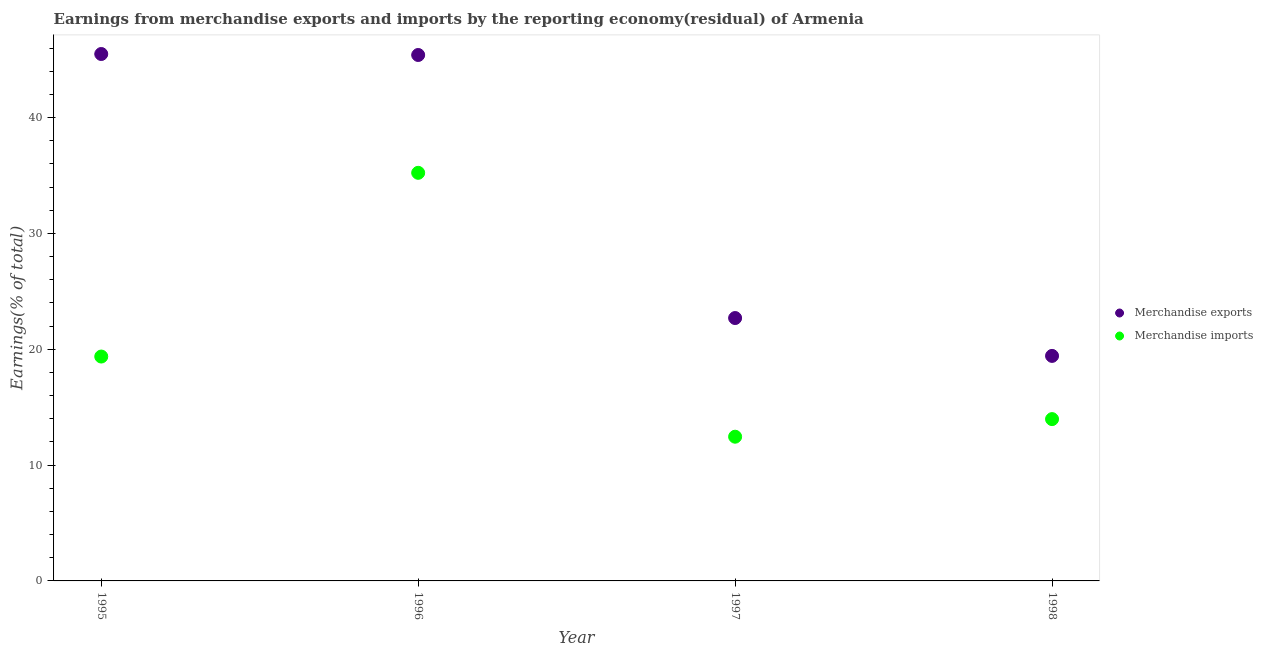Is the number of dotlines equal to the number of legend labels?
Ensure brevity in your answer.  Yes. What is the earnings from merchandise exports in 1996?
Give a very brief answer. 45.4. Across all years, what is the maximum earnings from merchandise imports?
Keep it short and to the point. 35.23. Across all years, what is the minimum earnings from merchandise imports?
Your response must be concise. 12.45. In which year was the earnings from merchandise imports maximum?
Provide a short and direct response. 1996. What is the total earnings from merchandise imports in the graph?
Provide a short and direct response. 81.01. What is the difference between the earnings from merchandise imports in 1995 and that in 1997?
Ensure brevity in your answer.  6.92. What is the difference between the earnings from merchandise exports in 1996 and the earnings from merchandise imports in 1998?
Your response must be concise. 31.43. What is the average earnings from merchandise imports per year?
Provide a short and direct response. 20.25. In the year 1995, what is the difference between the earnings from merchandise imports and earnings from merchandise exports?
Ensure brevity in your answer.  -26.12. What is the ratio of the earnings from merchandise exports in 1995 to that in 1997?
Your answer should be very brief. 2. What is the difference between the highest and the second highest earnings from merchandise exports?
Offer a very short reply. 0.08. What is the difference between the highest and the lowest earnings from merchandise exports?
Provide a succinct answer. 26.06. Is the sum of the earnings from merchandise imports in 1995 and 1996 greater than the maximum earnings from merchandise exports across all years?
Give a very brief answer. Yes. Is the earnings from merchandise exports strictly greater than the earnings from merchandise imports over the years?
Provide a succinct answer. Yes. Is the earnings from merchandise imports strictly less than the earnings from merchandise exports over the years?
Make the answer very short. Yes. How many dotlines are there?
Give a very brief answer. 2. How many years are there in the graph?
Offer a terse response. 4. Are the values on the major ticks of Y-axis written in scientific E-notation?
Your answer should be compact. No. Does the graph contain any zero values?
Provide a succinct answer. No. Does the graph contain grids?
Give a very brief answer. No. Where does the legend appear in the graph?
Offer a very short reply. Center right. How many legend labels are there?
Give a very brief answer. 2. What is the title of the graph?
Your answer should be very brief. Earnings from merchandise exports and imports by the reporting economy(residual) of Armenia. Does "Male labourers" appear as one of the legend labels in the graph?
Give a very brief answer. No. What is the label or title of the Y-axis?
Offer a terse response. Earnings(% of total). What is the Earnings(% of total) of Merchandise exports in 1995?
Ensure brevity in your answer.  45.48. What is the Earnings(% of total) in Merchandise imports in 1995?
Make the answer very short. 19.37. What is the Earnings(% of total) of Merchandise exports in 1996?
Ensure brevity in your answer.  45.4. What is the Earnings(% of total) of Merchandise imports in 1996?
Give a very brief answer. 35.23. What is the Earnings(% of total) of Merchandise exports in 1997?
Your answer should be compact. 22.69. What is the Earnings(% of total) of Merchandise imports in 1997?
Provide a succinct answer. 12.45. What is the Earnings(% of total) of Merchandise exports in 1998?
Provide a succinct answer. 19.42. What is the Earnings(% of total) of Merchandise imports in 1998?
Your answer should be very brief. 13.97. Across all years, what is the maximum Earnings(% of total) in Merchandise exports?
Offer a very short reply. 45.48. Across all years, what is the maximum Earnings(% of total) in Merchandise imports?
Provide a short and direct response. 35.23. Across all years, what is the minimum Earnings(% of total) of Merchandise exports?
Offer a terse response. 19.42. Across all years, what is the minimum Earnings(% of total) in Merchandise imports?
Keep it short and to the point. 12.45. What is the total Earnings(% of total) in Merchandise exports in the graph?
Your answer should be very brief. 133. What is the total Earnings(% of total) of Merchandise imports in the graph?
Your response must be concise. 81.01. What is the difference between the Earnings(% of total) of Merchandise exports in 1995 and that in 1996?
Your answer should be compact. 0.08. What is the difference between the Earnings(% of total) of Merchandise imports in 1995 and that in 1996?
Your answer should be very brief. -15.86. What is the difference between the Earnings(% of total) of Merchandise exports in 1995 and that in 1997?
Provide a succinct answer. 22.79. What is the difference between the Earnings(% of total) in Merchandise imports in 1995 and that in 1997?
Offer a terse response. 6.92. What is the difference between the Earnings(% of total) in Merchandise exports in 1995 and that in 1998?
Make the answer very short. 26.06. What is the difference between the Earnings(% of total) of Merchandise imports in 1995 and that in 1998?
Your answer should be compact. 5.4. What is the difference between the Earnings(% of total) in Merchandise exports in 1996 and that in 1997?
Your answer should be compact. 22.71. What is the difference between the Earnings(% of total) in Merchandise imports in 1996 and that in 1997?
Ensure brevity in your answer.  22.78. What is the difference between the Earnings(% of total) of Merchandise exports in 1996 and that in 1998?
Ensure brevity in your answer.  25.98. What is the difference between the Earnings(% of total) in Merchandise imports in 1996 and that in 1998?
Provide a succinct answer. 21.26. What is the difference between the Earnings(% of total) of Merchandise exports in 1997 and that in 1998?
Make the answer very short. 3.27. What is the difference between the Earnings(% of total) of Merchandise imports in 1997 and that in 1998?
Offer a very short reply. -1.52. What is the difference between the Earnings(% of total) of Merchandise exports in 1995 and the Earnings(% of total) of Merchandise imports in 1996?
Give a very brief answer. 10.26. What is the difference between the Earnings(% of total) in Merchandise exports in 1995 and the Earnings(% of total) in Merchandise imports in 1997?
Provide a succinct answer. 33.03. What is the difference between the Earnings(% of total) in Merchandise exports in 1995 and the Earnings(% of total) in Merchandise imports in 1998?
Your response must be concise. 31.52. What is the difference between the Earnings(% of total) in Merchandise exports in 1996 and the Earnings(% of total) in Merchandise imports in 1997?
Offer a terse response. 32.95. What is the difference between the Earnings(% of total) of Merchandise exports in 1996 and the Earnings(% of total) of Merchandise imports in 1998?
Offer a terse response. 31.43. What is the difference between the Earnings(% of total) of Merchandise exports in 1997 and the Earnings(% of total) of Merchandise imports in 1998?
Ensure brevity in your answer.  8.72. What is the average Earnings(% of total) of Merchandise exports per year?
Offer a very short reply. 33.25. What is the average Earnings(% of total) of Merchandise imports per year?
Your answer should be very brief. 20.25. In the year 1995, what is the difference between the Earnings(% of total) of Merchandise exports and Earnings(% of total) of Merchandise imports?
Your response must be concise. 26.12. In the year 1996, what is the difference between the Earnings(% of total) of Merchandise exports and Earnings(% of total) of Merchandise imports?
Give a very brief answer. 10.17. In the year 1997, what is the difference between the Earnings(% of total) of Merchandise exports and Earnings(% of total) of Merchandise imports?
Your answer should be compact. 10.24. In the year 1998, what is the difference between the Earnings(% of total) in Merchandise exports and Earnings(% of total) in Merchandise imports?
Offer a terse response. 5.46. What is the ratio of the Earnings(% of total) in Merchandise exports in 1995 to that in 1996?
Your answer should be very brief. 1. What is the ratio of the Earnings(% of total) in Merchandise imports in 1995 to that in 1996?
Provide a succinct answer. 0.55. What is the ratio of the Earnings(% of total) of Merchandise exports in 1995 to that in 1997?
Give a very brief answer. 2. What is the ratio of the Earnings(% of total) of Merchandise imports in 1995 to that in 1997?
Give a very brief answer. 1.56. What is the ratio of the Earnings(% of total) of Merchandise exports in 1995 to that in 1998?
Ensure brevity in your answer.  2.34. What is the ratio of the Earnings(% of total) in Merchandise imports in 1995 to that in 1998?
Your answer should be very brief. 1.39. What is the ratio of the Earnings(% of total) of Merchandise exports in 1996 to that in 1997?
Your response must be concise. 2. What is the ratio of the Earnings(% of total) of Merchandise imports in 1996 to that in 1997?
Provide a short and direct response. 2.83. What is the ratio of the Earnings(% of total) in Merchandise exports in 1996 to that in 1998?
Your answer should be compact. 2.34. What is the ratio of the Earnings(% of total) in Merchandise imports in 1996 to that in 1998?
Offer a terse response. 2.52. What is the ratio of the Earnings(% of total) of Merchandise exports in 1997 to that in 1998?
Your response must be concise. 1.17. What is the ratio of the Earnings(% of total) of Merchandise imports in 1997 to that in 1998?
Give a very brief answer. 0.89. What is the difference between the highest and the second highest Earnings(% of total) of Merchandise exports?
Ensure brevity in your answer.  0.08. What is the difference between the highest and the second highest Earnings(% of total) of Merchandise imports?
Provide a short and direct response. 15.86. What is the difference between the highest and the lowest Earnings(% of total) in Merchandise exports?
Ensure brevity in your answer.  26.06. What is the difference between the highest and the lowest Earnings(% of total) of Merchandise imports?
Offer a very short reply. 22.78. 